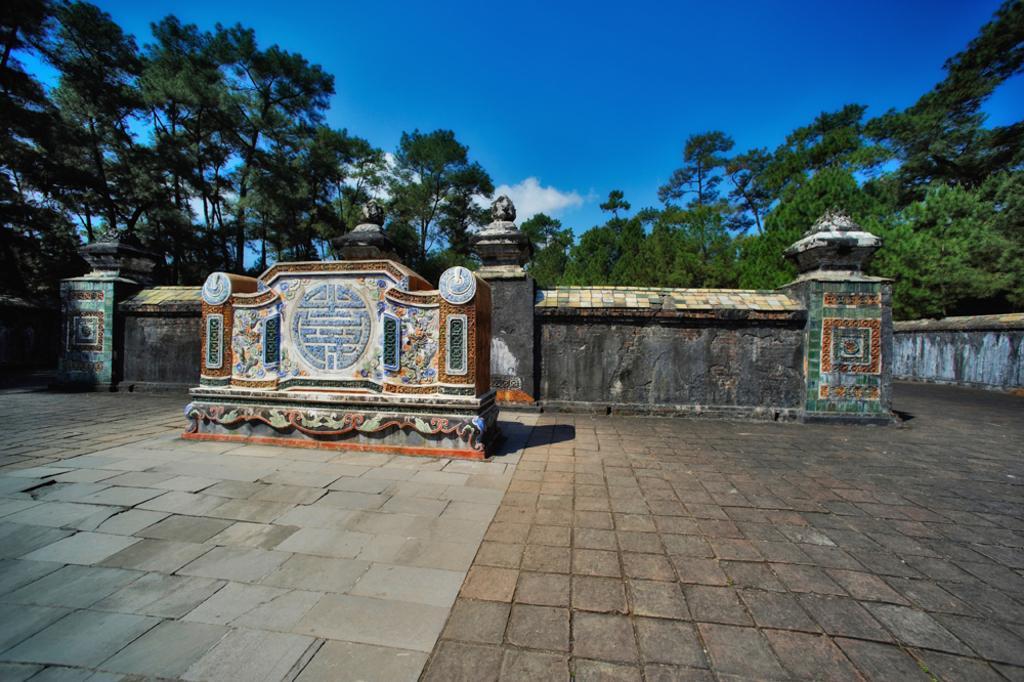Describe this image in one or two sentences. In the foreground we can see some constructions made of stones. At the bottom there is a stone surface. In the middle there are trees. At the top it is sky. 